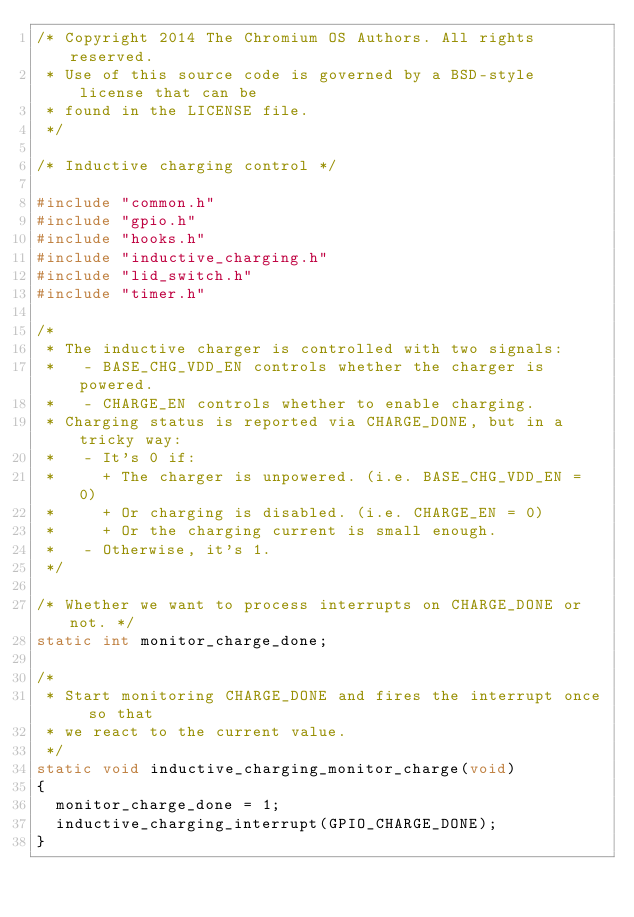<code> <loc_0><loc_0><loc_500><loc_500><_C_>/* Copyright 2014 The Chromium OS Authors. All rights reserved.
 * Use of this source code is governed by a BSD-style license that can be
 * found in the LICENSE file.
 */

/* Inductive charging control */

#include "common.h"
#include "gpio.h"
#include "hooks.h"
#include "inductive_charging.h"
#include "lid_switch.h"
#include "timer.h"

/*
 * The inductive charger is controlled with two signals:
 *   - BASE_CHG_VDD_EN controls whether the charger is powered.
 *   - CHARGE_EN controls whether to enable charging.
 * Charging status is reported via CHARGE_DONE, but in a tricky way:
 *   - It's 0 if:
 *     + The charger is unpowered. (i.e. BASE_CHG_VDD_EN = 0)
 *     + Or charging is disabled. (i.e. CHARGE_EN = 0)
 *     + Or the charging current is small enough.
 *   - Otherwise, it's 1.
 */

/* Whether we want to process interrupts on CHARGE_DONE or not. */
static int monitor_charge_done;

/*
 * Start monitoring CHARGE_DONE and fires the interrupt once so that
 * we react to the current value.
 */
static void inductive_charging_monitor_charge(void)
{
	monitor_charge_done = 1;
	inductive_charging_interrupt(GPIO_CHARGE_DONE);
}</code> 